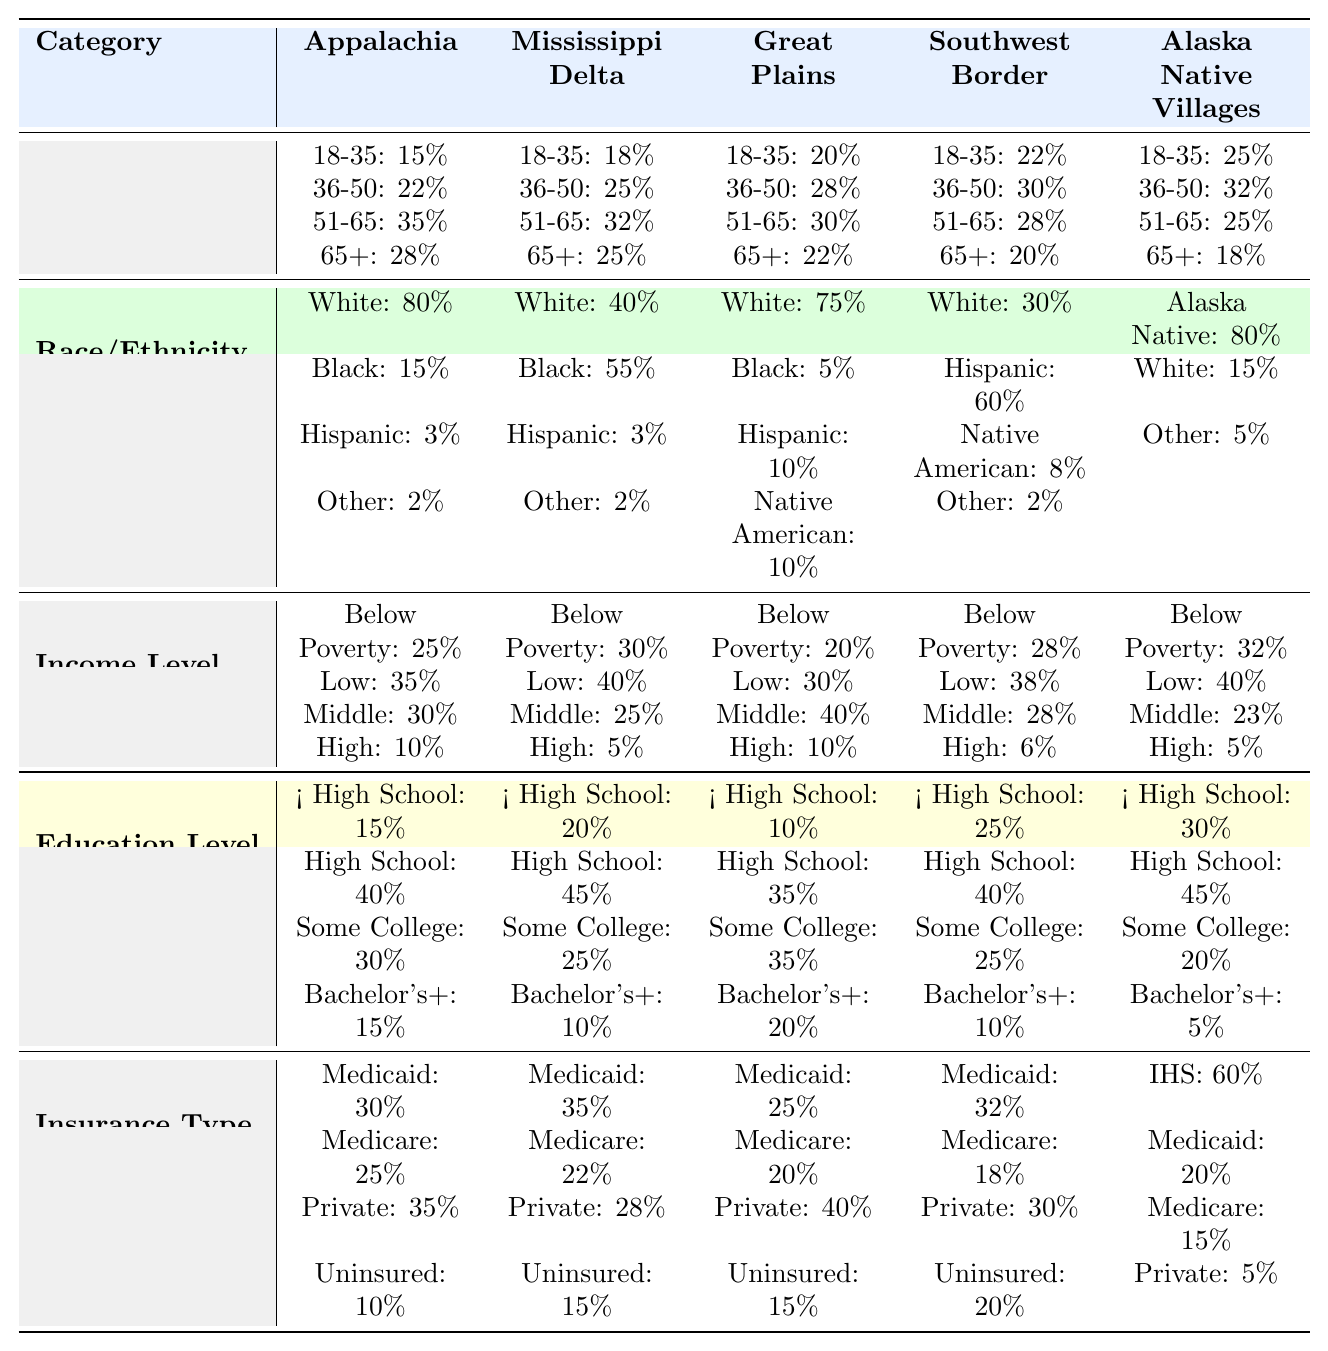What is the percentage of patients aged 51-65 in the Southwest Border region? According to the table, the percentage of patients aged 51-65 in the Southwest Border region is 28%.
Answer: 28% Which demographic has the highest representation in the Great Plains regarding race/ethnicity? The table shows that White individuals represent the highest percentage at 75% in the Great Plains.
Answer: White Among the income levels, which region has the highest percentage of patients below the poverty line? The Mississippi Delta has the highest percentage of patients below the poverty line at 30%.
Answer: Mississippi Delta What is the percentage of patients in Appalachia with a Bachelor's degree or higher? The table indicates that 15% of patients in Appalachia have a Bachelor's degree or higher.
Answer: 15% What percentage of patients in Alaska Native Villages are uninsured? The table shows that the percentage of patients uninsured in Alaska Native Villages is 5%.
Answer: 5% Which region has the highest percentage of Hispanic patients? The Southwest Border has the highest percentage of Hispanic patients at 60%.
Answer: Southwest Border What is the average percentage of patients aged 18-35 across all regions? The percentages for the 18-35 age group are 15%, 18%, 20%, 22%, and 25% for each region, and their sum is 100%, which divided by 5 regions gives an average of 20%.
Answer: 20% Is the percentage of patients with Medicare higher in the Mississippi Delta or the Great Plains? In the Mississippi Delta, the percentage is 22%, while in the Great Plains it is 20%, so the percentage is higher in the Mississippi Delta.
Answer: Yes Which age group has the lowest representation in Alaska Native Villages? The age group 65+ has the lowest representation in Alaska Native Villages at 18%.
Answer: 65+ What is the difference in percentage of low-income patients between Appalachia and the Great Plains? Appalachia has 35% low-income patients while the Great Plains has 30%, so the difference is 5%.
Answer: 5% 